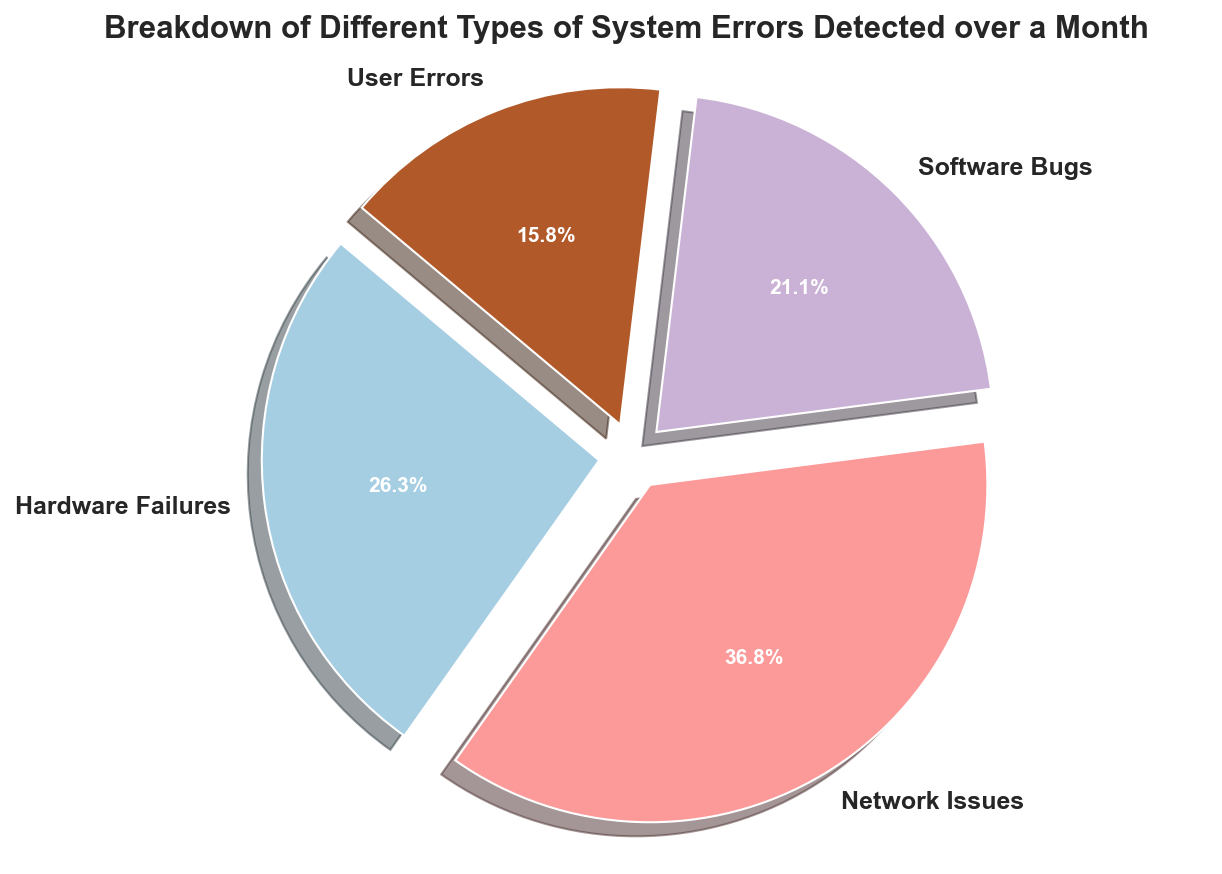Which error type has the highest count? By examining the pie chart, identify which segment is the largest and has the highest percentage. The "Network Issues" segment is the largest.
Answer: Network Issues Which error type has the smallest count? Look for the smallest segment in the pie chart. The "User Errors" segment is the smallest.
Answer: User Errors What percentage of the total errors are due to Hardware Failures and Software Bugs combined? From the pie chart, Hardware Failures account for 25% and Software Bugs for 20%. Combine them to get 25% + 20% = 45%.
Answer: 45% Compare the count of Network Issues and User Errors. By how much is one greater than the other? Network Issues account for 70 counts, and User Errors account for 30 counts. The difference is 70 - 30 = 40.
Answer: 40 If you combine User Errors and Hardware Failures, which category would they come closest to in percentage? User Errors are 15% and Hardware Failures are 25%, combining them gives 40%. The closest category is Software Bugs at 20%.
Answer: Software Bugs Rank the error types from the most to least frequent. The segments are visually compared by size: Network Issues (35%), Hardware Failures (25%), Software Bugs (20%), and User Errors (15%).
Answer: Network Issues > Hardware Failures > Software Bugs > User Errors Which two error types combined make up half of all errors? The combined percentage needs to be 50%. Combining Software Bugs (20%) and Hardware Failures (25%) gets close at 45%. Another combination, User Errors (15%) and Network Issues (35%) = 50%.
Answer: User Errors and Network Issues Is the percentage of Hardware Failures closer to the percentage of Network Issues or Software Bugs? Hardware Failures are 25%. The percentage of Network Issues is 35% and Software Bugs is 20%. The difference from Hardware Failures is calculated as follows:
Answer: Network Issues What visual attribute distinguishes each section of the pie chart? Each segment is separated by a slight explosion and is distinctly colored with different shades from the palette.
Answer: Exploded segments and different colors 